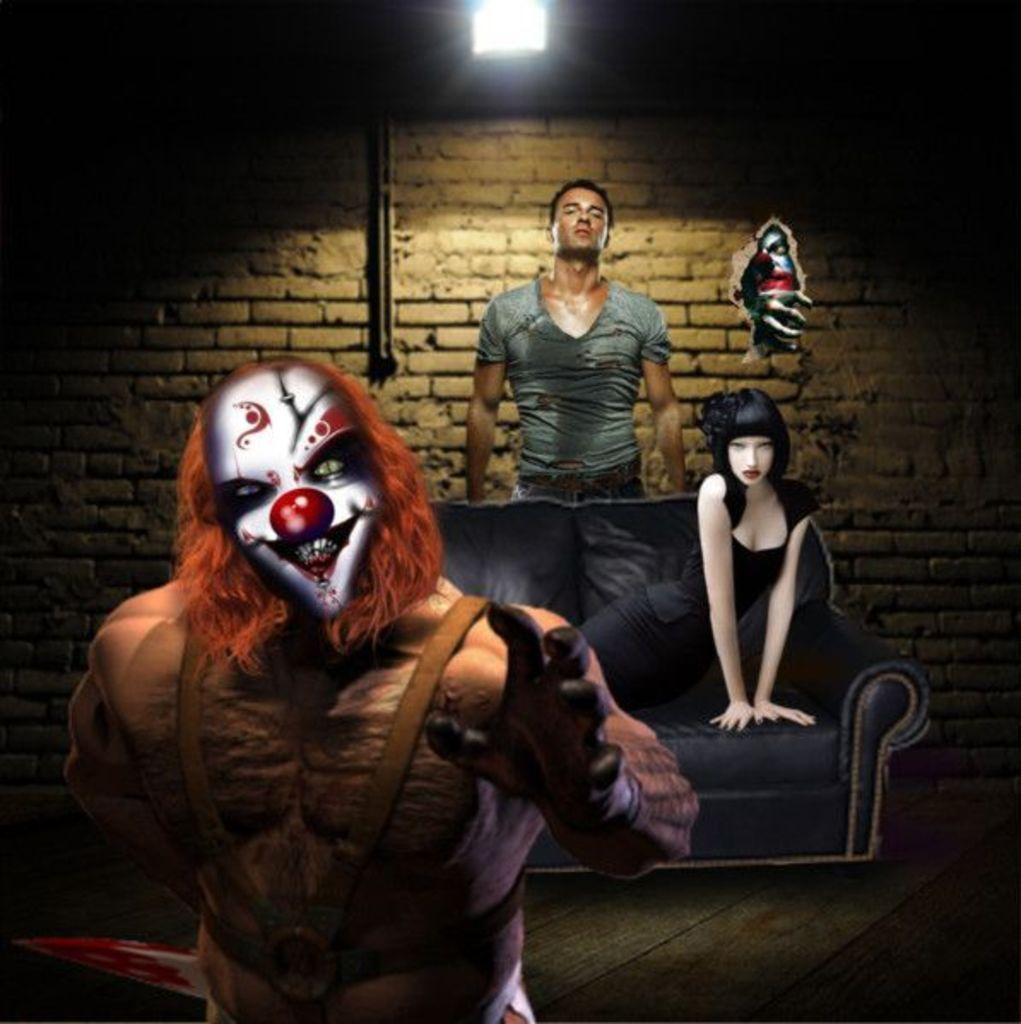What is depicted on the left side of the image? There is a monster picture on the left side of the image. What is the woman in the image doing? The woman is sitting on a sofa. Can you describe the man in the image? There is a man in the image. What is attached to the wall in the image? There is a pipe on the wall. What can be seen providing illumination in the image? There is a light in the image. How is the monster picture integrated into the wall? The monster picture appears to be coming from the wall, as if it is a part of the wall. How many passengers are visible in the image? There is no reference to passengers in the image; it features a monster picture, a woman sitting on a sofa, a man, a pipe on the wall, a light, and a monster picture integrated into the wall. What type of steel is used to construct the wall in the image? There is no mention of steel or any construction materials in the image; it only shows a monster picture, a woman sitting on a sofa, a man, a pipe on the wall, and a light. 